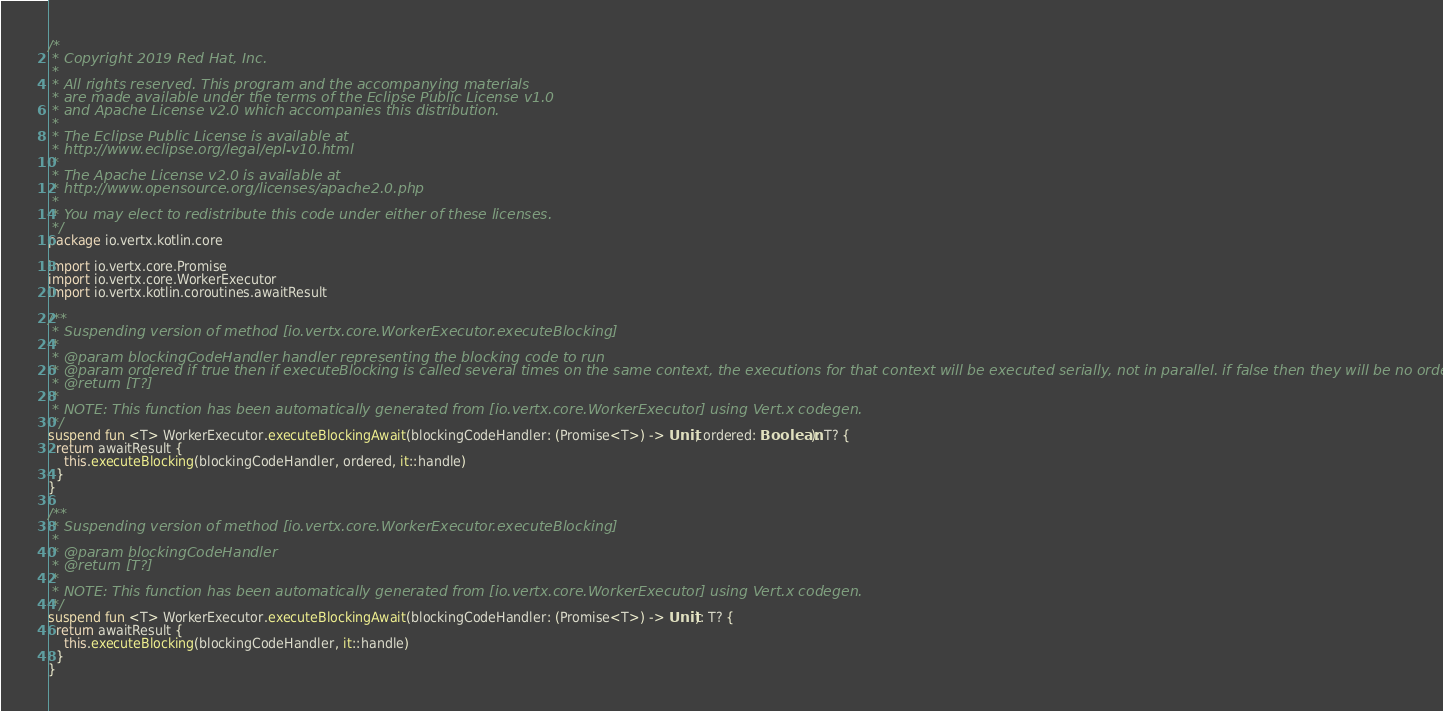<code> <loc_0><loc_0><loc_500><loc_500><_Kotlin_>/*
 * Copyright 2019 Red Hat, Inc.
 *
 * All rights reserved. This program and the accompanying materials
 * are made available under the terms of the Eclipse Public License v1.0
 * and Apache License v2.0 which accompanies this distribution.
 *
 * The Eclipse Public License is available at
 * http://www.eclipse.org/legal/epl-v10.html
 *
 * The Apache License v2.0 is available at
 * http://www.opensource.org/licenses/apache2.0.php
 *
 * You may elect to redistribute this code under either of these licenses.
 */
package io.vertx.kotlin.core

import io.vertx.core.Promise
import io.vertx.core.WorkerExecutor
import io.vertx.kotlin.coroutines.awaitResult

/**
 * Suspending version of method [io.vertx.core.WorkerExecutor.executeBlocking]
 *
 * @param blockingCodeHandler handler representing the blocking code to run
 * @param ordered if true then if executeBlocking is called several times on the same context, the executions for that context will be executed serially, not in parallel. if false then they will be no ordering guarantees
 * @return [T?]
 *
 * NOTE: This function has been automatically generated from [io.vertx.core.WorkerExecutor] using Vert.x codegen.
 */
suspend fun <T> WorkerExecutor.executeBlockingAwait(blockingCodeHandler: (Promise<T>) -> Unit, ordered: Boolean): T? {
  return awaitResult {
    this.executeBlocking(blockingCodeHandler, ordered, it::handle)
  }
}

/**
 * Suspending version of method [io.vertx.core.WorkerExecutor.executeBlocking]
 *
 * @param blockingCodeHandler 
 * @return [T?]
 *
 * NOTE: This function has been automatically generated from [io.vertx.core.WorkerExecutor] using Vert.x codegen.
 */
suspend fun <T> WorkerExecutor.executeBlockingAwait(blockingCodeHandler: (Promise<T>) -> Unit): T? {
  return awaitResult {
    this.executeBlocking(blockingCodeHandler, it::handle)
  }
}

</code> 